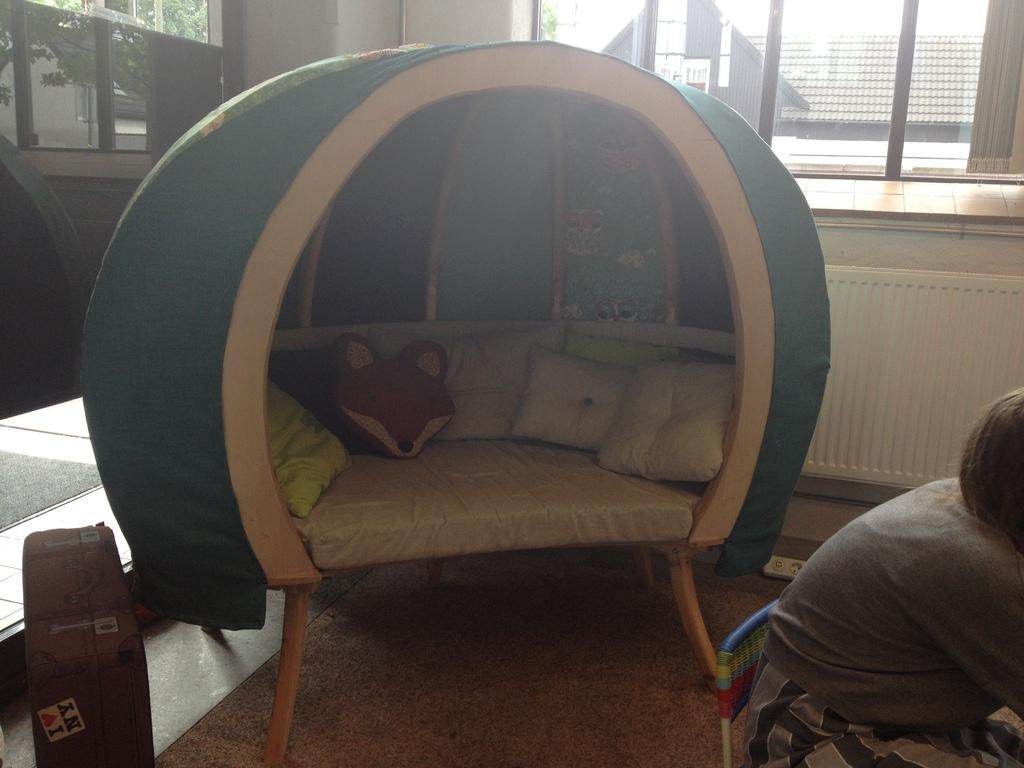In one or two sentences, can you explain what this image depicts? There is a person sitting on chair and we can see pillows on bed and trunk box on floor. On the background we can see glass windows,through this glass windows we can see rooftop and trees. 